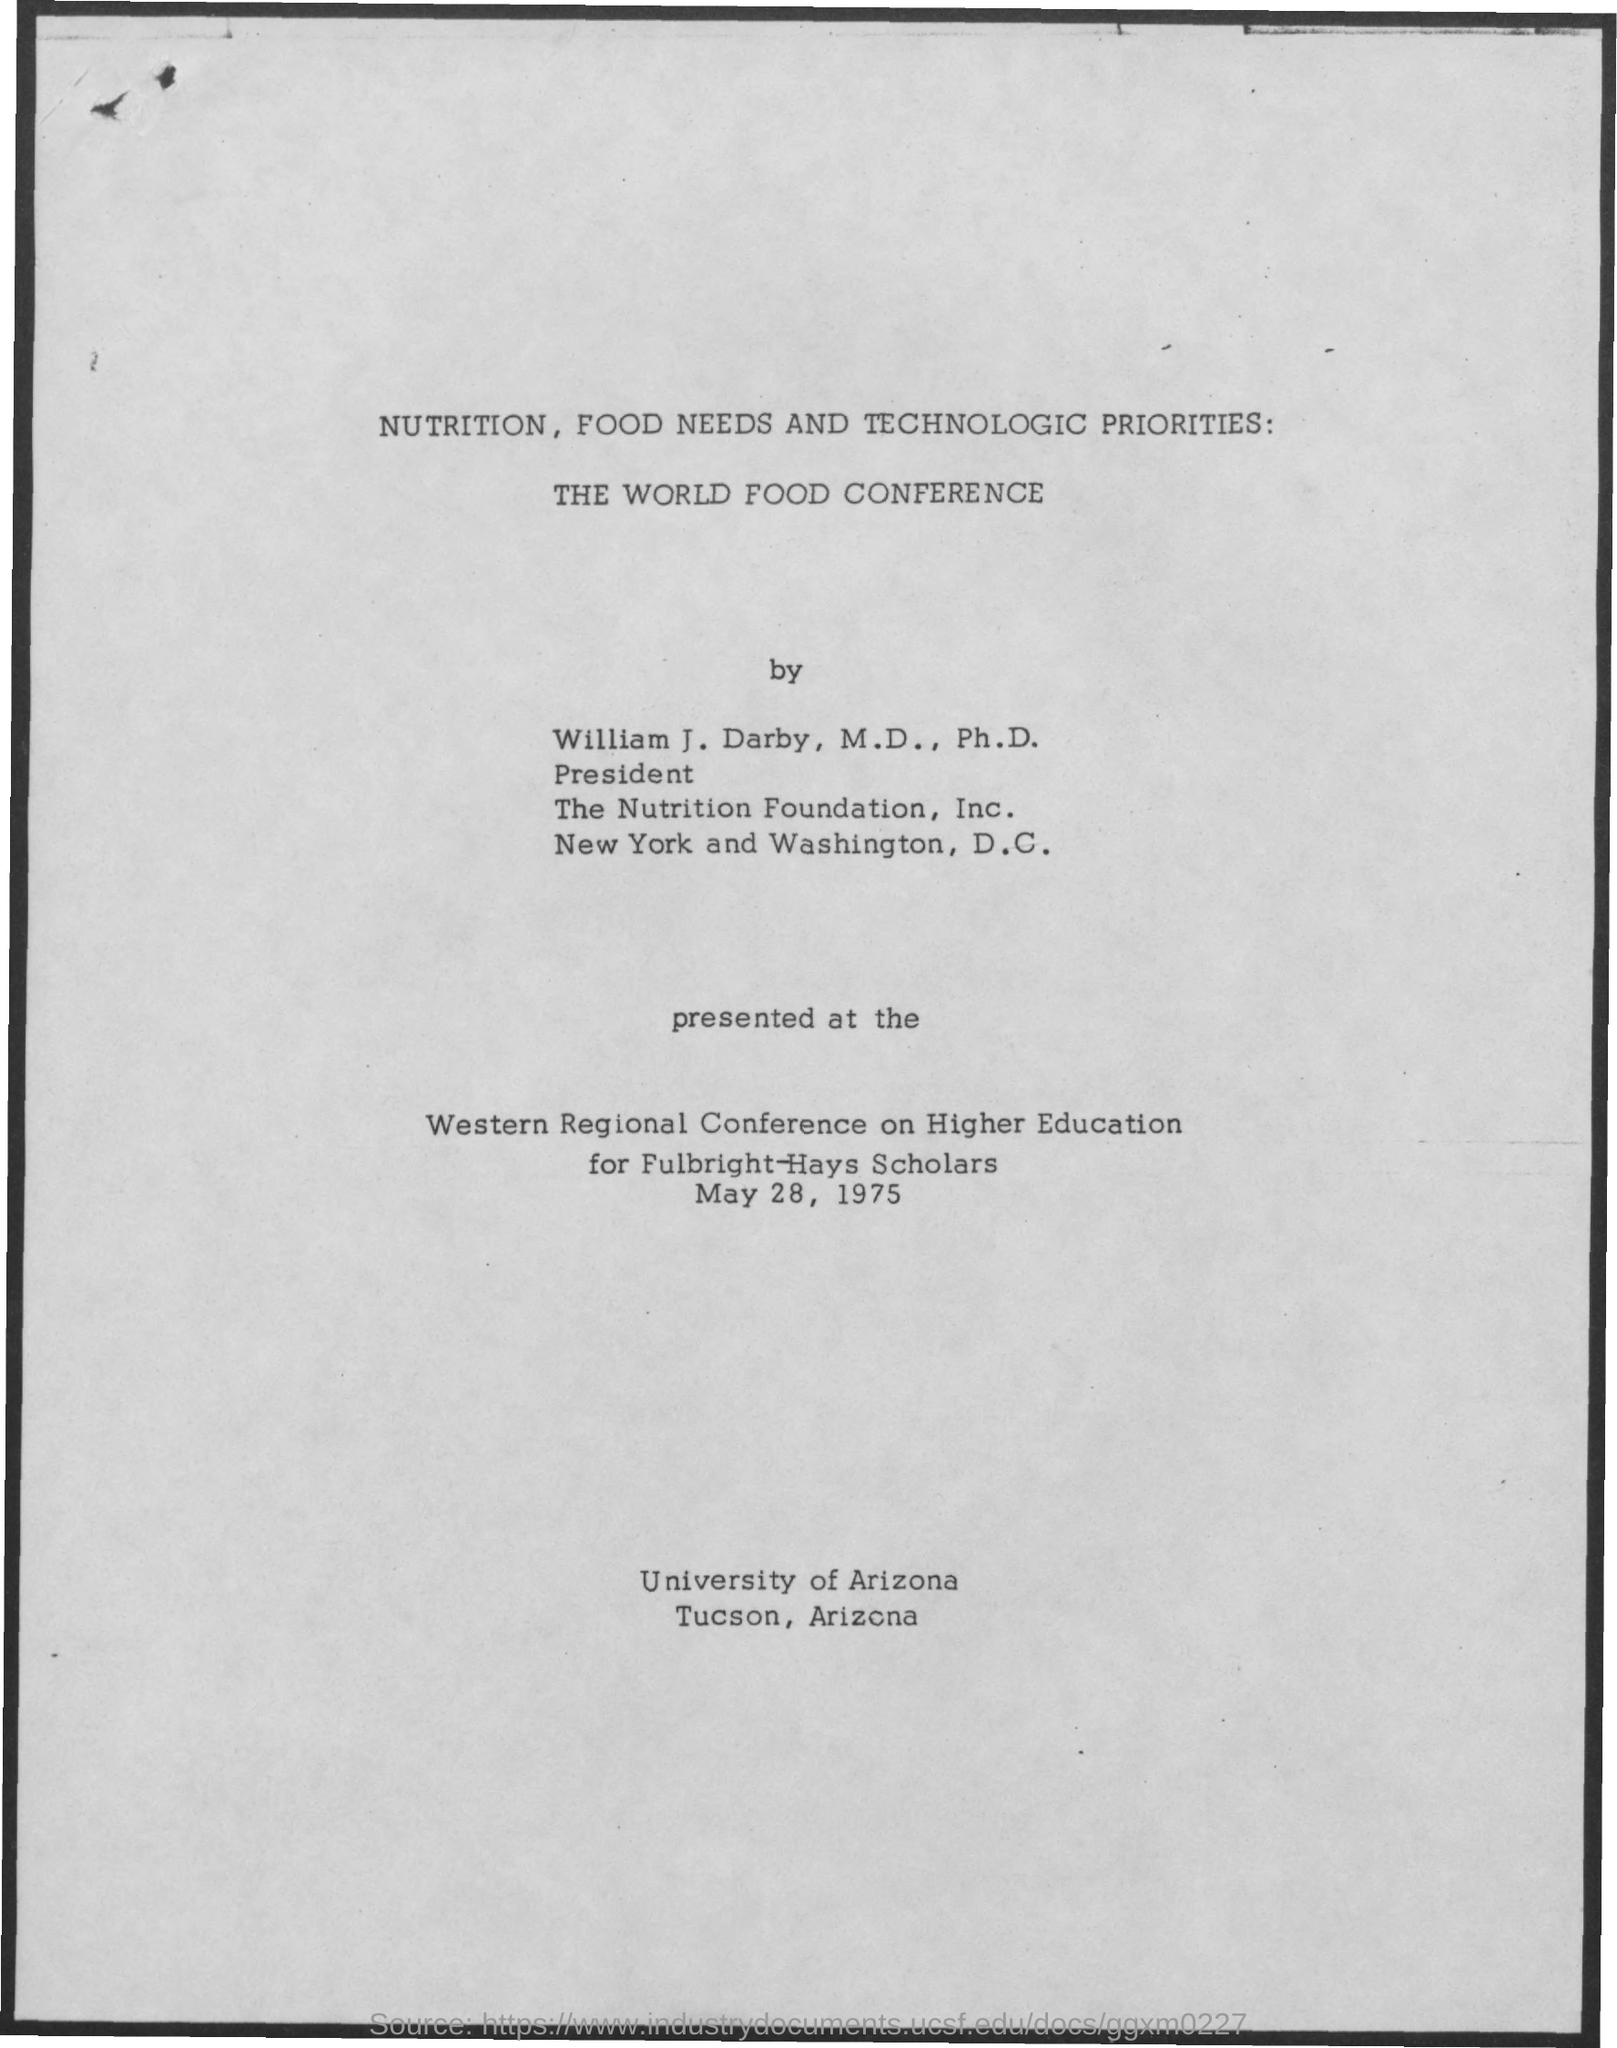Give some essential details in this illustration. The Western regional conference on Higher Education was held on May 28, 1975. The Western regional conference on Higher Education was primarily aimed at Fulbright-Hays scholars. 